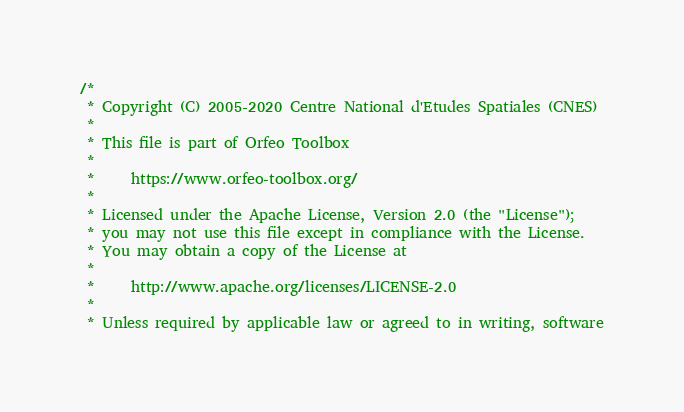Convert code to text. <code><loc_0><loc_0><loc_500><loc_500><_C_>/*
 * Copyright (C) 2005-2020 Centre National d'Etudes Spatiales (CNES)
 *
 * This file is part of Orfeo Toolbox
 *
 *     https://www.orfeo-toolbox.org/
 *
 * Licensed under the Apache License, Version 2.0 (the "License");
 * you may not use this file except in compliance with the License.
 * You may obtain a copy of the License at
 *
 *     http://www.apache.org/licenses/LICENSE-2.0
 *
 * Unless required by applicable law or agreed to in writing, software</code> 